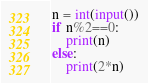<code> <loc_0><loc_0><loc_500><loc_500><_Python_>n = int(input())
if n%2==0:
    print(n)
else:
    print(2*n)</code> 